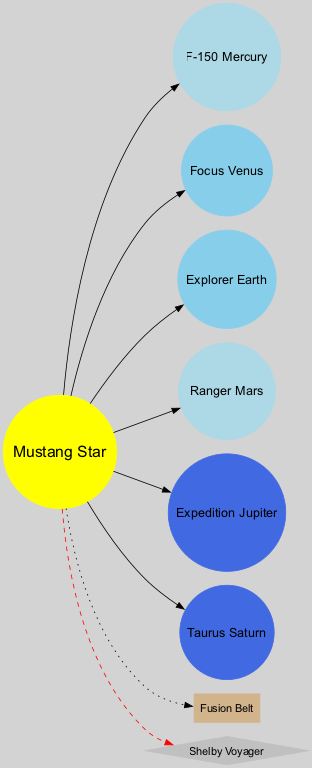What is the name of the star at the center of the diagram? The center of the diagram contains a node labeled "Mustang Star". This node represents the sun in this Ford-inspired solar system.
Answer: Mustang Star How many planets are there in the diagram? By counting the nodes representing the planets, there are six nodes labeled with the names of planets. Each one corresponds to a distinct planet in this solar system.
Answer: 6 Which planet is closest to the sun? The diagram shows the first planet in order as "F-150 Mercury", which is connected directly to the "Mustang Star" node, indicating it is the closest planet to the sun.
Answer: F-150 Mercury What is the largest planet in this solar system? "Expedition Jupiter" is indicated as a large planet among the provided names. The size descriptor is explicitly stated alongside the planet's name in the diagram, making it clear that it is the largest.
Answer: Expedition Jupiter How does the "Fusion Belt" relate to the sun? The "Fusion Belt" node is connected to the "Mustang Star" node via a dotted edge, which indicates a less direct relationship compared to the solid lines connecting the planets. The dotted line means it is an asteroid belt that relies on the sun's gravity but is separate from the planets.
Answer: Dotted edge Which planet is represented with a medium size in the diagram? Both "Focus Venus" and "Explorer Earth" are labeled with a medium size, according to the size descriptors associated with their respective nodes, indicating two planets share this characteristic.
Answer: Focus Venus, Explorer Earth What type of shape is the "Shelby Voyager"? The "Shelby Voyager" is represented as a diamond shape in the diagram, which signifies it as a spacecraft, distinct from the circular shapes of the planets and the box shape of the asteroid belt.
Answer: Diamond Which planet is furthest from the sun? "Taurus Saturn" is the sixth planet in the order listed in the diagram and is therefore the furthest from the sun, considering the arrangement of planets.
Answer: Taurus Saturn 